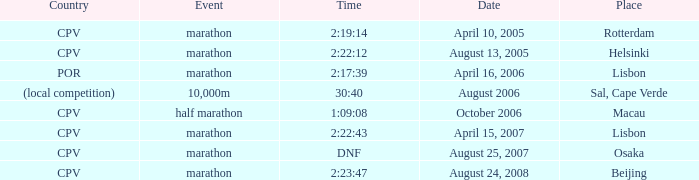What is the Date of the Event with a Time of 2:23:47? August 24, 2008. 